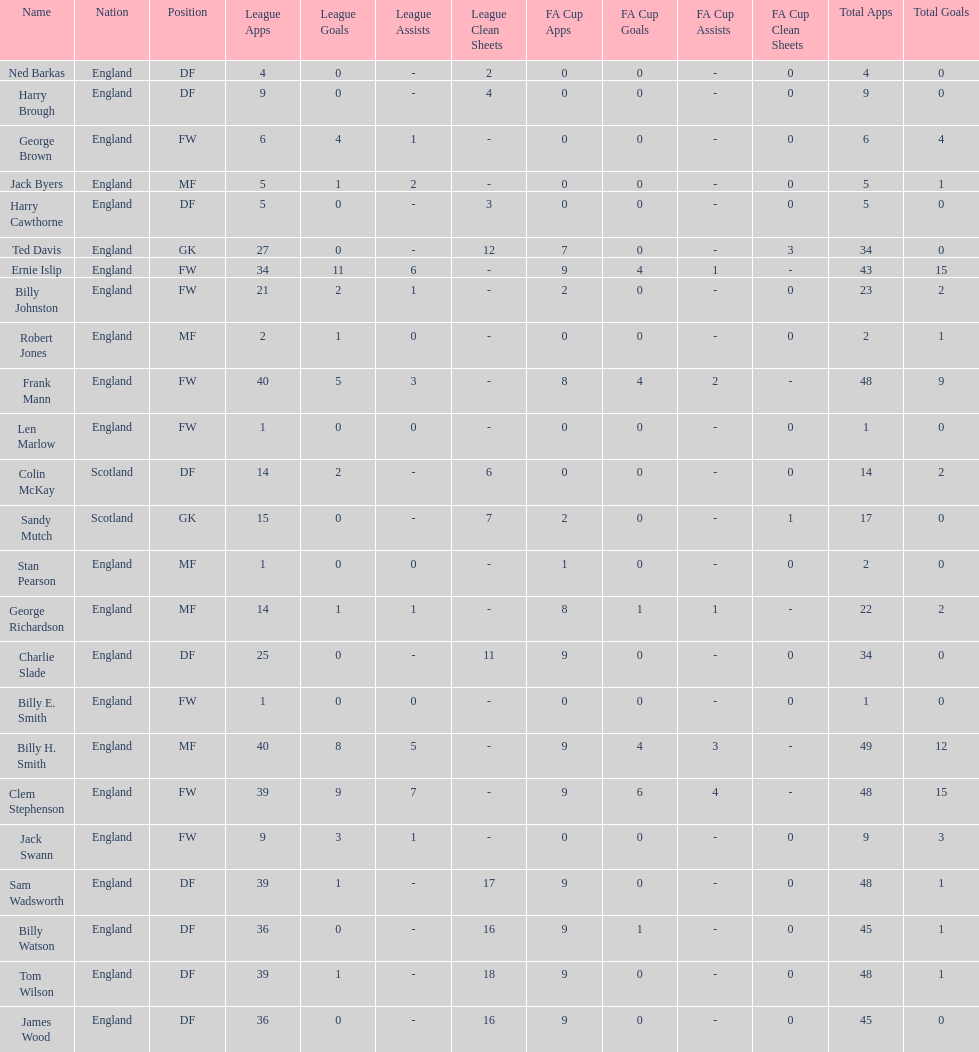What is the average number of scotland's total apps? 15.5. 